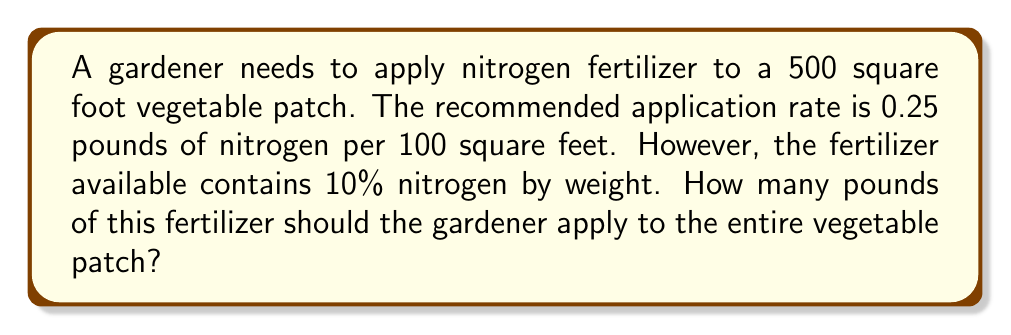Help me with this question. Let's solve this problem step by step:

1. First, calculate the total amount of pure nitrogen needed:
   - The recommended rate is 0.25 lbs per 100 sq ft
   - For 500 sq ft: $\frac{500}{100} \times 0.25 = 1.25$ lbs of pure nitrogen

2. Convert the percentage of nitrogen in the fertilizer to a decimal:
   - 10% = $\frac{10}{100} = 0.10$

3. Use the formula: $\text{Total fertilizer} = \frac{\text{Pure nitrogen needed}}{\text{Nitrogen concentration}}$
   
   $$\text{Total fertilizer} = \frac{1.25 \text{ lbs}}{0.10} = 12.5 \text{ lbs}$$

Therefore, the gardener should apply 12.5 pounds of the 10% nitrogen fertilizer to the 500 square foot vegetable patch.
Answer: 12.5 lbs 